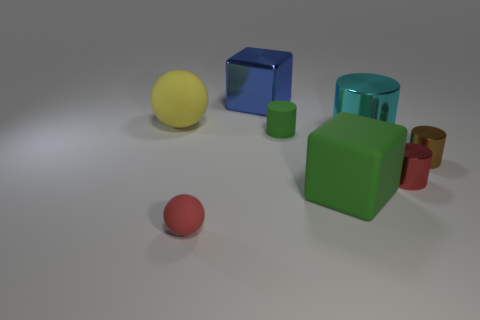Subtract all large shiny cylinders. How many cylinders are left? 3 Subtract all red cylinders. How many cylinders are left? 3 Add 2 large gray metal balls. How many objects exist? 10 Subtract all cyan cylinders. Subtract all green spheres. How many cylinders are left? 3 Subtract 0 gray cylinders. How many objects are left? 8 Subtract all balls. How many objects are left? 6 Subtract all small brown metallic cylinders. Subtract all red objects. How many objects are left? 5 Add 8 big cyan metallic things. How many big cyan metallic things are left? 9 Add 2 big green objects. How many big green objects exist? 3 